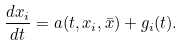<formula> <loc_0><loc_0><loc_500><loc_500>\frac { d x _ { i } } { d t } = a ( t , x _ { i } , \bar { x } ) + g _ { i } ( t ) .</formula> 